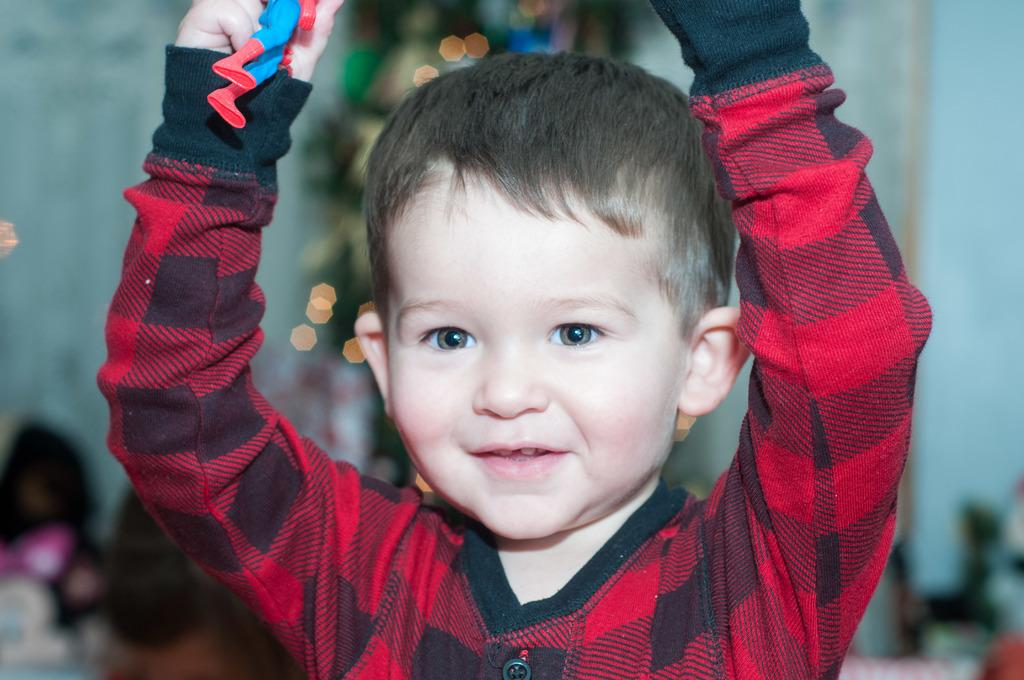What is the main subject of the image? The main subject of the image is a kid. What is the kid doing in the image? The kid is standing in the image. What expression does the kid have? The kid is smiling in the image. What type of vein can be seen on the kid's forehead in the image? There is no visible vein on the kid's forehead in the image. What type of light source is illuminating the kid in the image? The provided facts do not mention any specific light source in the image. 